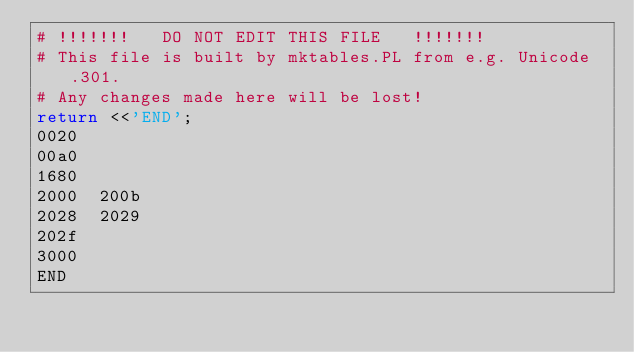<code> <loc_0><loc_0><loc_500><loc_500><_Perl_># !!!!!!!   DO NOT EDIT THIS FILE   !!!!!!! 
# This file is built by mktables.PL from e.g. Unicode.301.
# Any changes made here will be lost!
return <<'END';
0020	
00a0	
1680	
2000	200b
2028	2029
202f	
3000	
END
</code> 